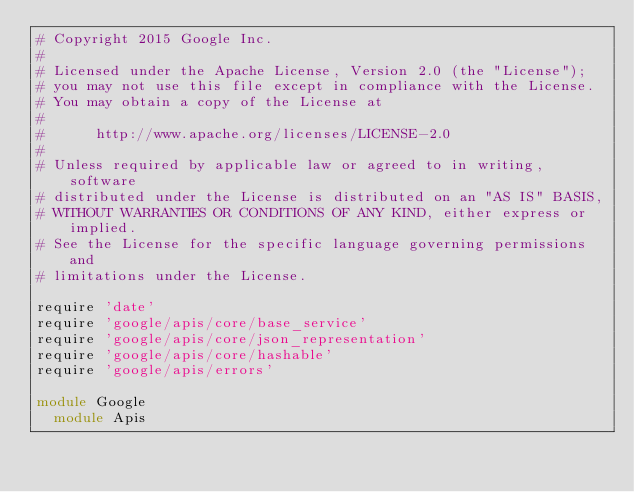<code> <loc_0><loc_0><loc_500><loc_500><_Ruby_># Copyright 2015 Google Inc.
#
# Licensed under the Apache License, Version 2.0 (the "License");
# you may not use this file except in compliance with the License.
# You may obtain a copy of the License at
#
#      http://www.apache.org/licenses/LICENSE-2.0
#
# Unless required by applicable law or agreed to in writing, software
# distributed under the License is distributed on an "AS IS" BASIS,
# WITHOUT WARRANTIES OR CONDITIONS OF ANY KIND, either express or implied.
# See the License for the specific language governing permissions and
# limitations under the License.

require 'date'
require 'google/apis/core/base_service'
require 'google/apis/core/json_representation'
require 'google/apis/core/hashable'
require 'google/apis/errors'

module Google
  module Apis</code> 